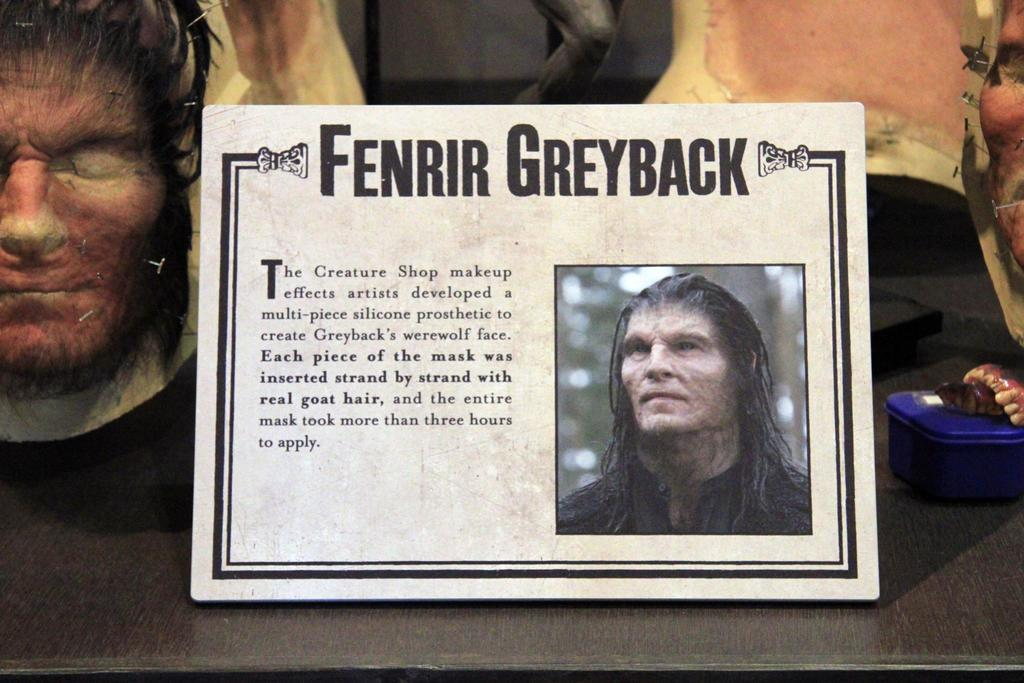What is the main object in the image? There is a photo frame in the image. What is shown inside the photo frame? The photo frame contains a depiction of a person. Are there any other objects visible in the image? Yes, there are other objects on the table in the image. What type of border is present around the person in the photo frame? There is no mention of a border around the person in the photo frame in the provided facts. 